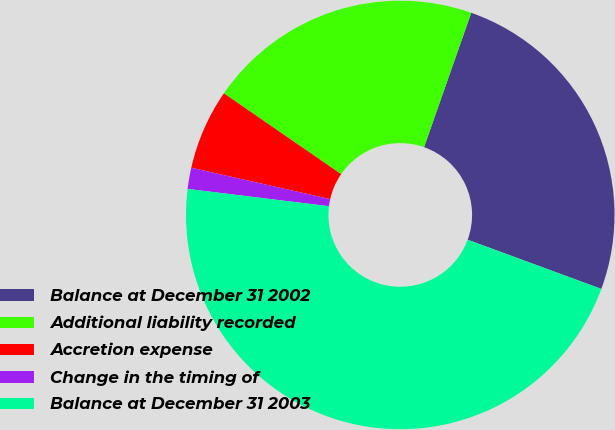Convert chart. <chart><loc_0><loc_0><loc_500><loc_500><pie_chart><fcel>Balance at December 31 2002<fcel>Additional liability recorded<fcel>Accretion expense<fcel>Change in the timing of<fcel>Balance at December 31 2003<nl><fcel>25.24%<fcel>20.77%<fcel>6.07%<fcel>1.6%<fcel>46.33%<nl></chart> 